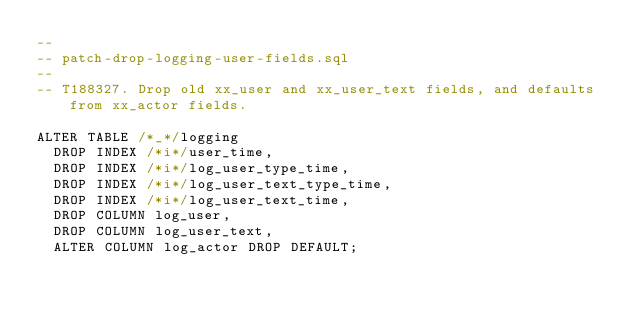Convert code to text. <code><loc_0><loc_0><loc_500><loc_500><_SQL_>--
-- patch-drop-logging-user-fields.sql
--
-- T188327. Drop old xx_user and xx_user_text fields, and defaults from xx_actor fields.

ALTER TABLE /*_*/logging
  DROP INDEX /*i*/user_time,
  DROP INDEX /*i*/log_user_type_time,
  DROP INDEX /*i*/log_user_text_type_time,
  DROP INDEX /*i*/log_user_text_time,
  DROP COLUMN log_user,
  DROP COLUMN log_user_text,
  ALTER COLUMN log_actor DROP DEFAULT;
</code> 